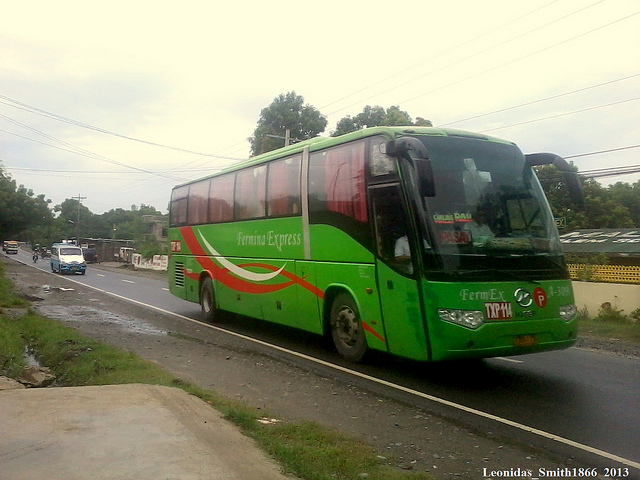<image>Does the bus have passengers? I don't know if the bus has passengers. It could possibly have passengers. Does the bus have passengers? I am not sure if the bus has passengers. However, it can be seen that there are passengers. 